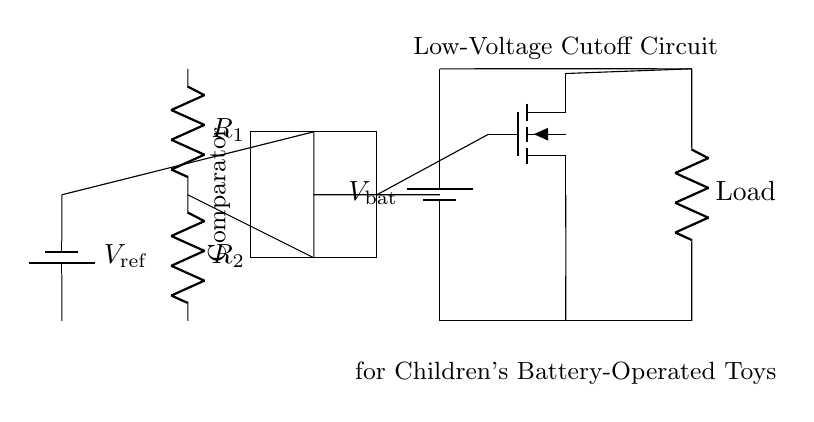What type of transistor is used in this circuit? The circuit diagram includes a symbol for a MOSFET, which indicates that the type of transistor used in this circuit is a MOSFET (metal-oxide-semiconductor field-effect transistor).
Answer: MOSFET What does the comparator do in this circuit? The comparator compares the voltage at its input with a reference voltage to determine whether to turn the MOSFET on or off, thereby controlling the power to the load based on battery voltage.
Answer: Control power What is the purpose of the voltage divider in this circuit? The voltage divider created by resistors R1 and R2 reduces the battery voltage to a level that the comparator can use to determine if the battery voltage has dropped below a certain threshold.
Answer: Reduce voltage What can be inferred if the load is not receiving power? If the load is not receiving power, it suggests the MOSFET is turned off, likely due to the battery voltage being below the cutoff voltage set by the comparator.
Answer: Battery low Which direction does current flow when the battery is supplying power? Current flows from the positive terminal of the battery through the load, through the MOSFET, and back to the negative terminal of the battery.
Answer: Positive to negative What happens if the reference voltage is set too high? If the reference voltage is set too high, the circuit may not turn off the MOSFET even when the battery voltage drops below a safe level, potentially damaging the battery and the circuit.
Answer: Risks damage What is the component labeled "Load" in this circuit? The "Load" component represents any device (like a toy) that draws current from the battery and is powered by it; it operates while the circuit is active.
Answer: Device powered by battery 